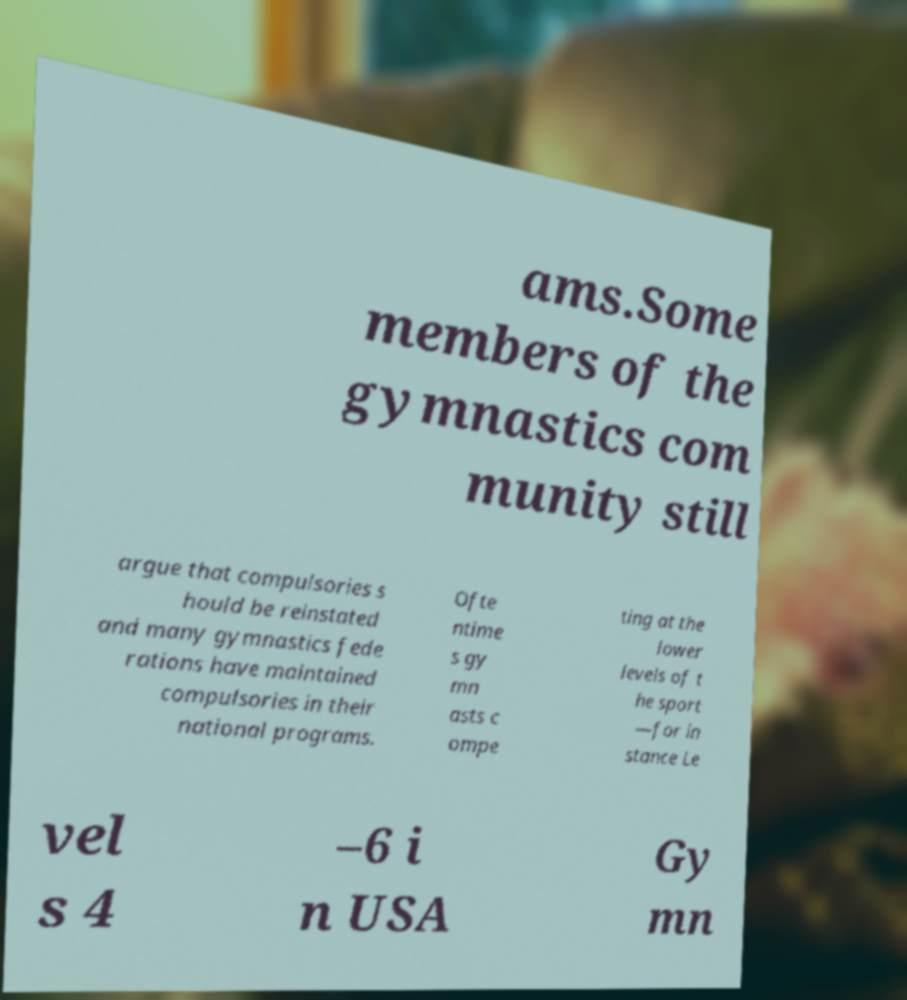Could you extract and type out the text from this image? ams.Some members of the gymnastics com munity still argue that compulsories s hould be reinstated and many gymnastics fede rations have maintained compulsories in their national programs. Ofte ntime s gy mn asts c ompe ting at the lower levels of t he sport —for in stance Le vel s 4 –6 i n USA Gy mn 